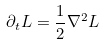<formula> <loc_0><loc_0><loc_500><loc_500>\partial _ { t } L = \frac { 1 } { 2 } \nabla ^ { 2 } L</formula> 